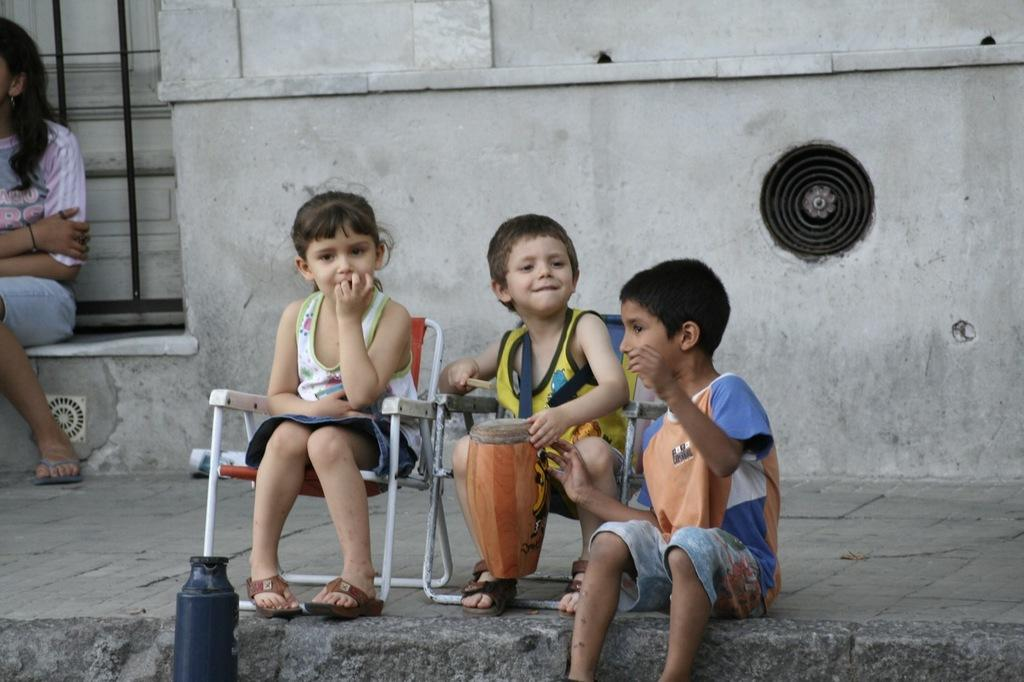How many kids are present in the image? There are two kids in the image. What is the position of the first kid? One of the kids is sitting on a chair. What is the first kid holding? The kid on the chair is holding a musical drum. What is the position of the woman in the image? The woman is sitting on a wall. What is the position of the second kid? The second kid is sitting on a wall. What type of rock is the second kid using as a drumstick in the image? There is no rock present in the image, and the second kid is not using any drumstick. 